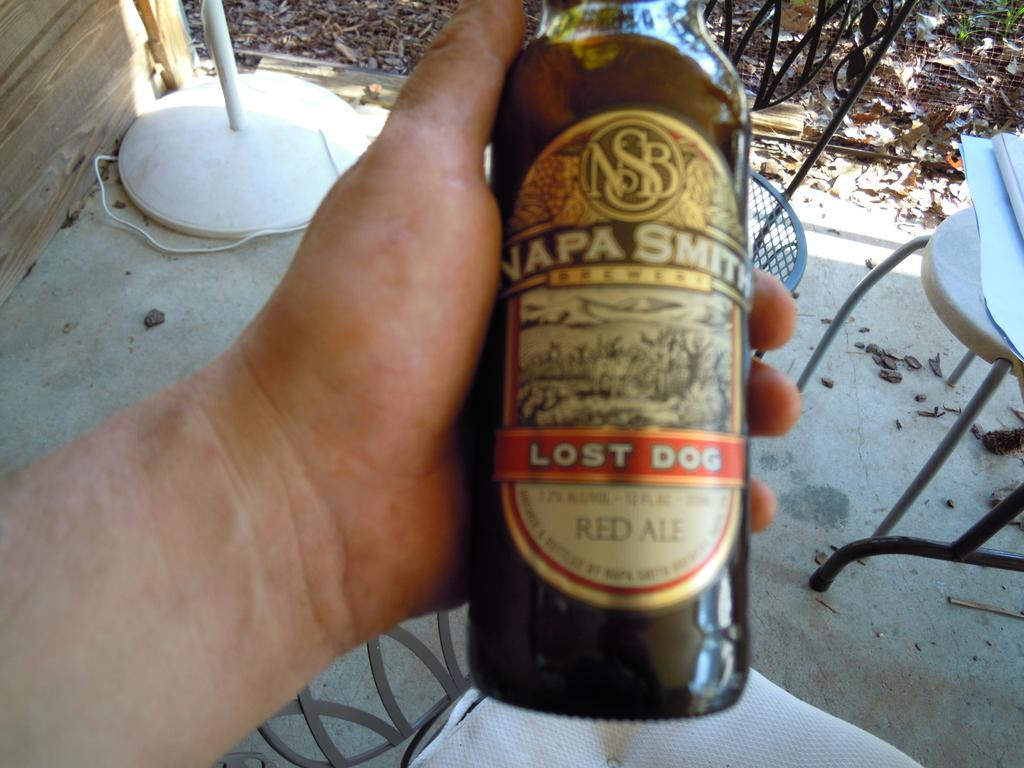Provide a one-sentence caption for the provided image. a bottle of beer called napa smith being held by a person. 